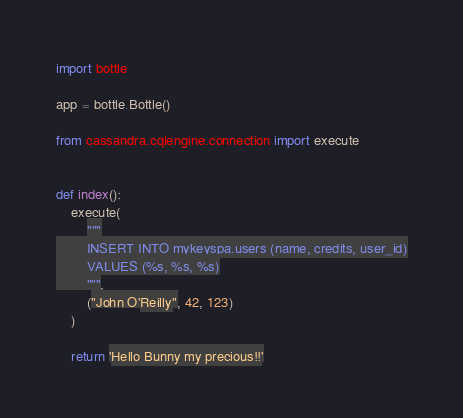Convert code to text. <code><loc_0><loc_0><loc_500><loc_500><_Python_>import bottle

app = bottle.Bottle()

from cassandra.cqlengine.connection import execute


def index():
    execute(
        """
        INSERT INTO mykeyspa.users (name, credits, user_id)
        VALUES (%s, %s, %s)
        """,
        ("John O'Reilly", 42, 123)
    )

    return 'Hello Bunny my precious!!'
</code> 